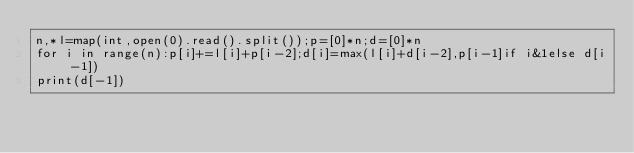Convert code to text. <code><loc_0><loc_0><loc_500><loc_500><_Cython_>n,*l=map(int,open(0).read().split());p=[0]*n;d=[0]*n
for i in range(n):p[i]+=l[i]+p[i-2];d[i]=max(l[i]+d[i-2],p[i-1]if i&1else d[i-1])
print(d[-1])
</code> 